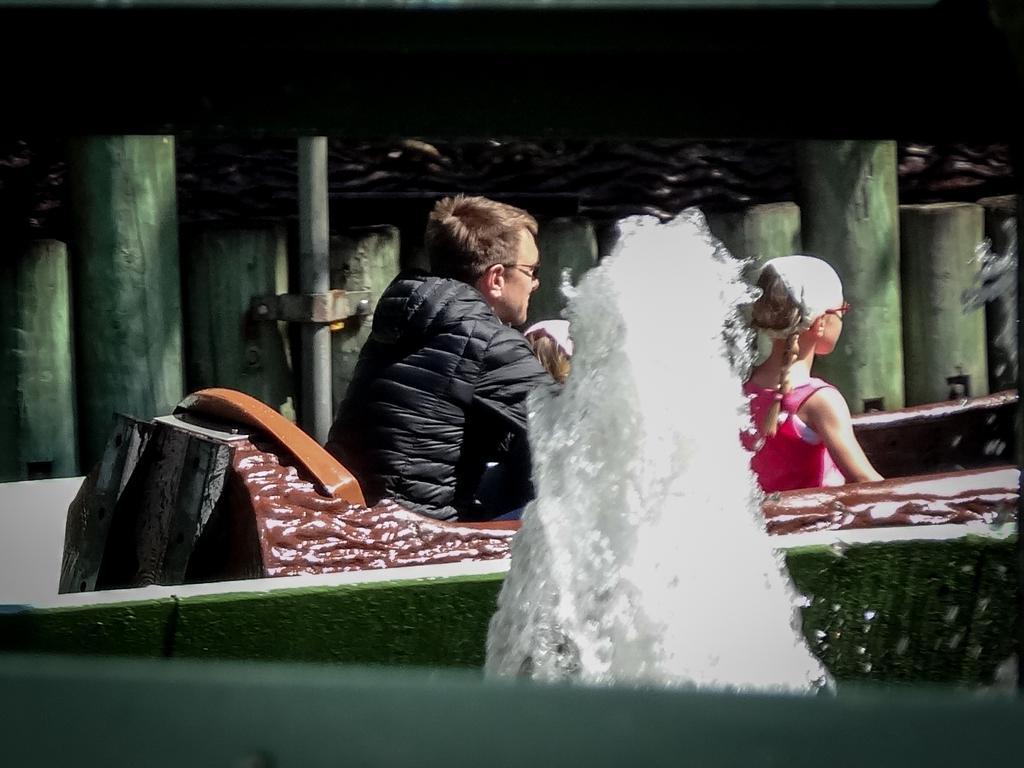How would you summarize this image in a sentence or two? In this image, I can see the man and two girls sitting on an object. This looks like a water fountain. These are the wooden pillars. I think this is a pole. 